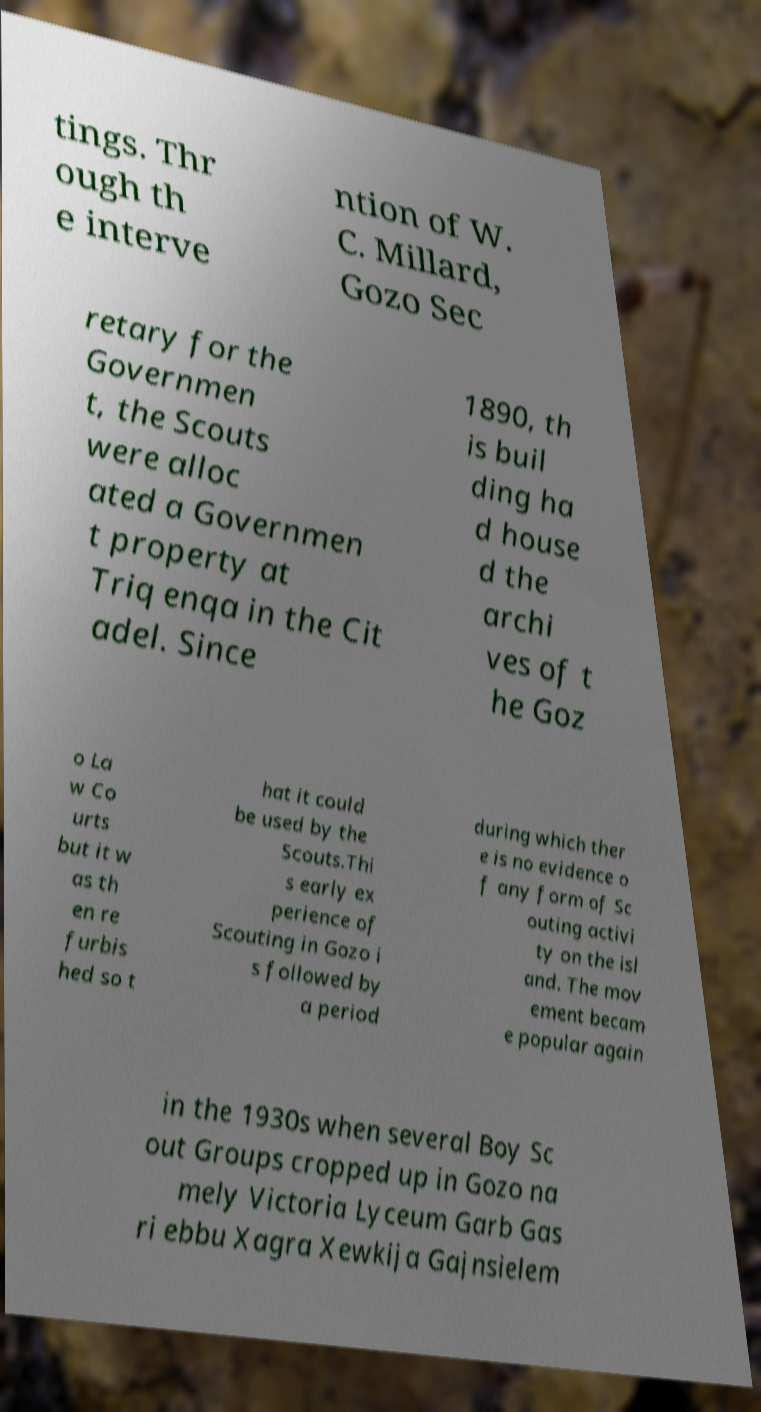Can you read and provide the text displayed in the image?This photo seems to have some interesting text. Can you extract and type it out for me? tings. Thr ough th e interve ntion of W. C. Millard, Gozo Sec retary for the Governmen t, the Scouts were alloc ated a Governmen t property at Triq enqa in the Cit adel. Since 1890, th is buil ding ha d house d the archi ves of t he Goz o La w Co urts but it w as th en re furbis hed so t hat it could be used by the Scouts.Thi s early ex perience of Scouting in Gozo i s followed by a period during which ther e is no evidence o f any form of Sc outing activi ty on the isl and. The mov ement becam e popular again in the 1930s when several Boy Sc out Groups cropped up in Gozo na mely Victoria Lyceum Garb Gas ri ebbu Xagra Xewkija Gajnsielem 